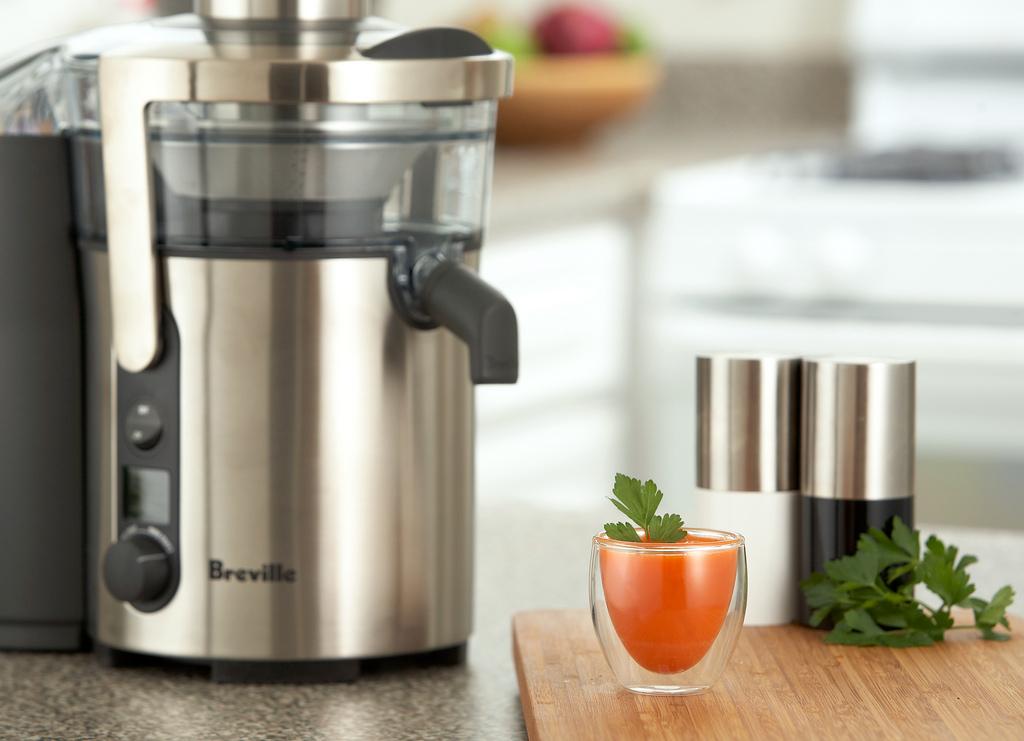What is the brand of this appliance?
Give a very brief answer. Breville. 